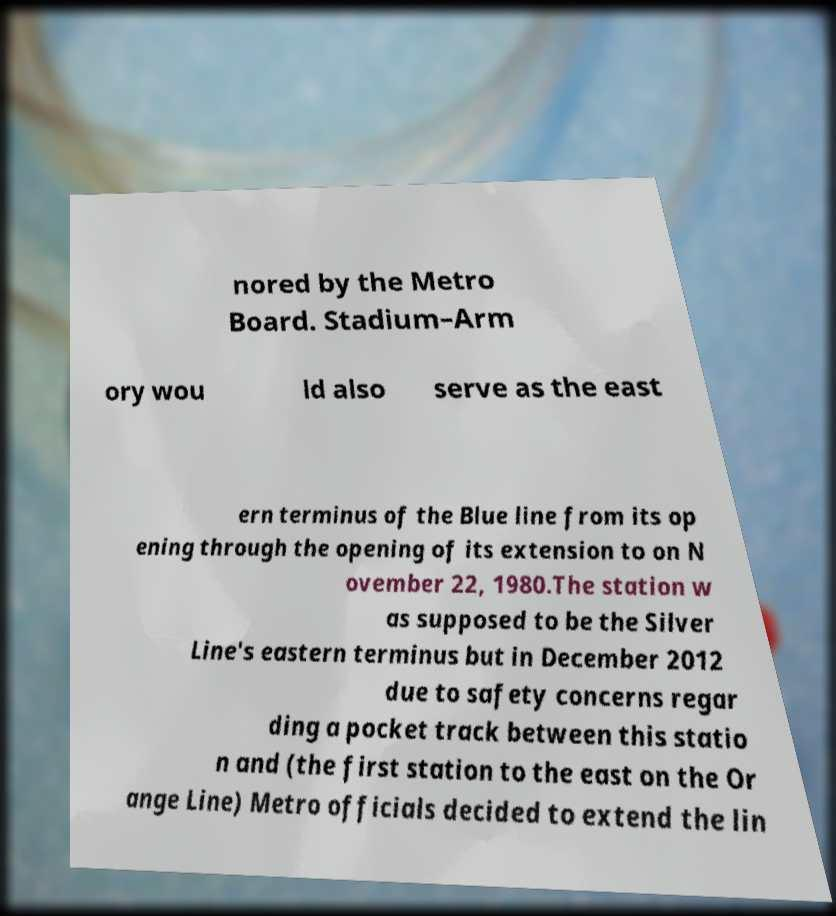Please identify and transcribe the text found in this image. nored by the Metro Board. Stadium–Arm ory wou ld also serve as the east ern terminus of the Blue line from its op ening through the opening of its extension to on N ovember 22, 1980.The station w as supposed to be the Silver Line's eastern terminus but in December 2012 due to safety concerns regar ding a pocket track between this statio n and (the first station to the east on the Or ange Line) Metro officials decided to extend the lin 